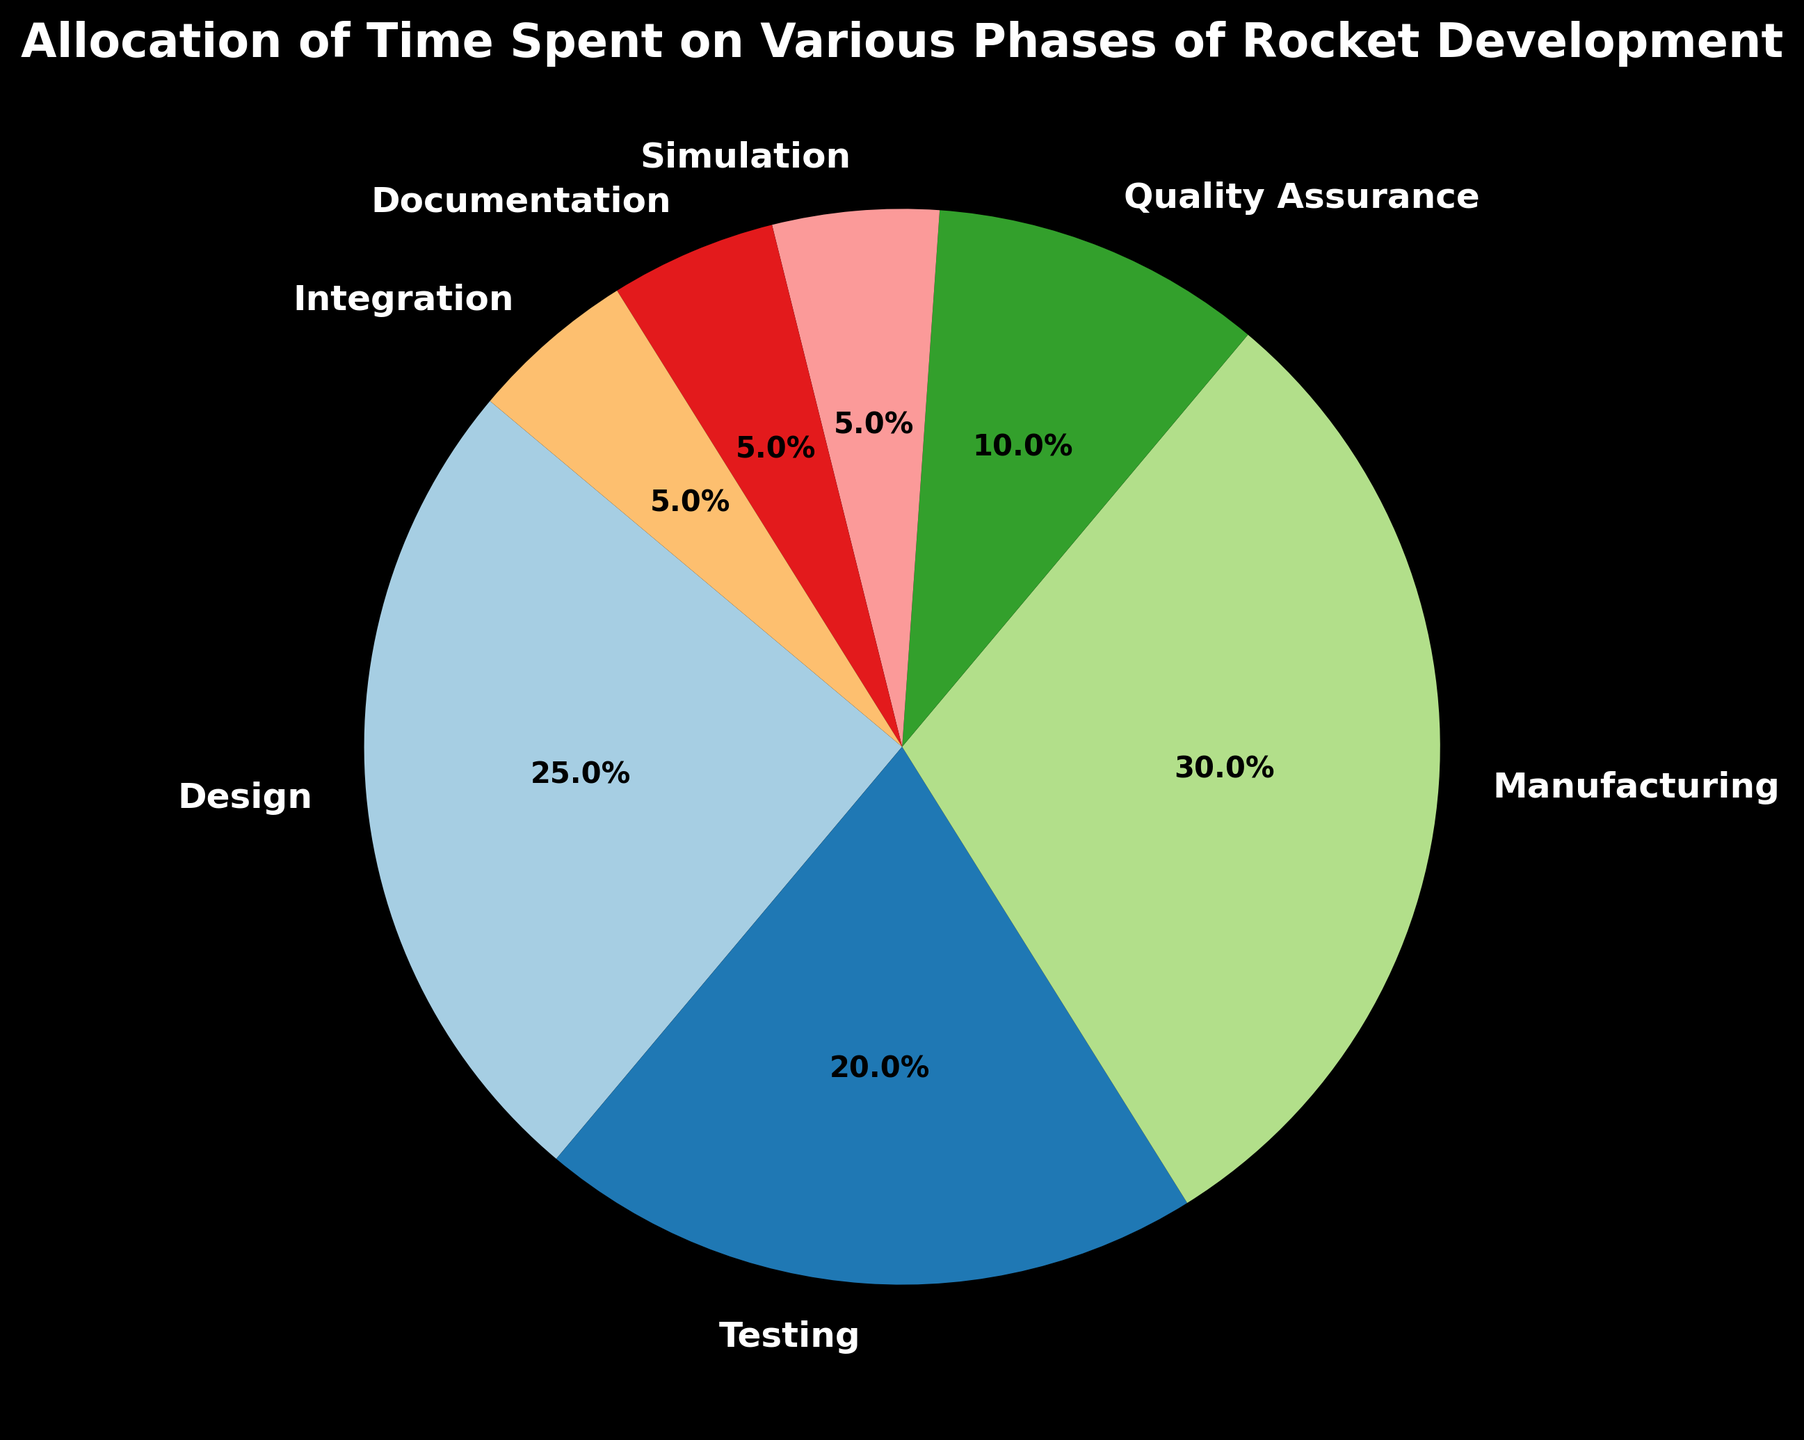Which phase takes up the largest percentage of time? By visually scanning the pie chart, identify which segment is the largest. The Manufacturing phase has the largest segment.
Answer: Manufacturing What percentage of time is spent on Testing and Simulation combined? The chart shows 20% for Testing and 5% for Simulation. Add these two values: 20% + 5% = 25%.
Answer: 25% Which phase has the smallest allocation of time? Visually identify the smallest segment in the pie chart. Both Simulation, Documentation, and Integration have the smallest segments at 5% each. Choose one: Simulation.
Answer: Simulation Is more time spent on Design or Quality Assurance? Compare the sectors labeled Design and Quality Assurance. Design is 25%, and Quality Assurance is 10%. 25% is greater than 10%.
Answer: Design How much more time is spent on Manufacturing than Documentation? The chart shows 30% for Manufacturing and 5% for Documentation. Subtract the smaller percentage from the larger one: 30% - 5% = 25%.
Answer: 25% Does the combined time for Integration, Simulation, and Documentation exceed the time for Testing? Add the percentages for Integration, Simulation, and Documentation: 5% + 5% + 5% = 15%. Compare this with the Testing time of 20%. 15% is less than 20%.
Answer: No What is the total percentage of time spent on the phases that are less than 10%? Identify the phases with percentages less than 10%: Simulation (5%), Documentation (5%), Integration (5%). Sum them up: 5% + 5% + 5% = 15%.
Answer: 15% Rank the phases from the most time-consuming to the least time-consuming. Order the percentages from highest to lowest: Manufacturing (30%), Design (25%), Testing (20%), Quality Assurance (10%), Simulation, Documentation, Integration (each 5%).
Answer: Manufacturing, Design, Testing, Quality Assurance, Simulation, Documentation, Integration Which phases take up the same amount of time? Identify the phases with the same percentages: Simulation (5%), Documentation (5%), Integration (5%).
Answer: Simulation, Documentation, Integration 